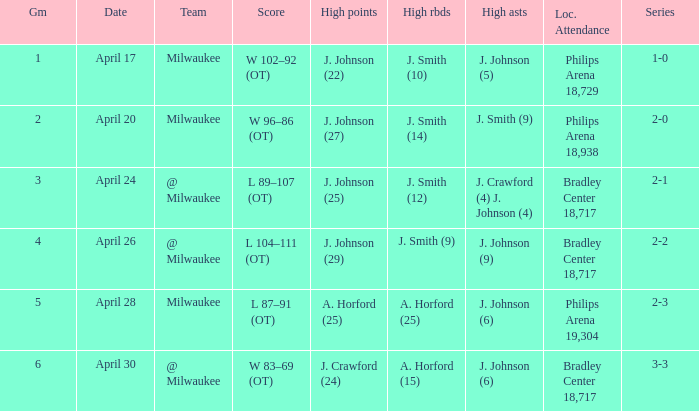What was the score in game 6? W 83–69 (OT). 